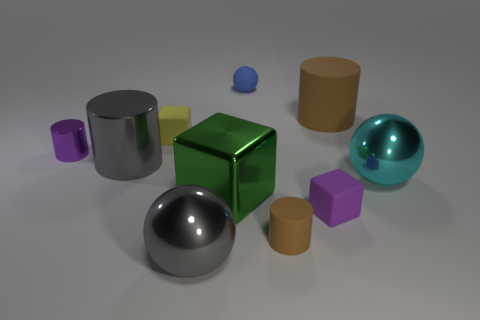There is a purple thing on the right side of the big gray metal object that is on the left side of the large gray metallic sphere; are there any rubber spheres that are to the right of it?
Provide a short and direct response. No. Are there any metallic objects in front of the tiny blue thing?
Provide a succinct answer. Yes. What number of other cylinders have the same color as the small matte cylinder?
Offer a terse response. 1. There is a cyan sphere that is the same material as the gray cylinder; what is its size?
Your response must be concise. Large. There is a metal object that is to the right of the brown rubber object behind the brown thing on the left side of the tiny purple rubber object; what size is it?
Offer a terse response. Large. How big is the cube on the right side of the tiny brown rubber object?
Keep it short and to the point. Small. How many purple objects are either big rubber cylinders or cylinders?
Ensure brevity in your answer.  1. Is there a cyan matte object that has the same size as the yellow rubber block?
Ensure brevity in your answer.  No. What material is the gray cylinder that is the same size as the green cube?
Provide a short and direct response. Metal. There is a rubber cube behind the small purple matte cube; is it the same size as the matte cube that is in front of the big shiny cube?
Your response must be concise. Yes. 